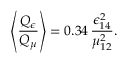<formula> <loc_0><loc_0><loc_500><loc_500>\left \langle \frac { Q _ { \epsilon } } { Q _ { \mu } } \right \rangle = 0 . 3 4 \, \frac { \epsilon _ { 1 4 } ^ { 2 } } { \mu _ { 1 2 } ^ { 2 } } .</formula> 